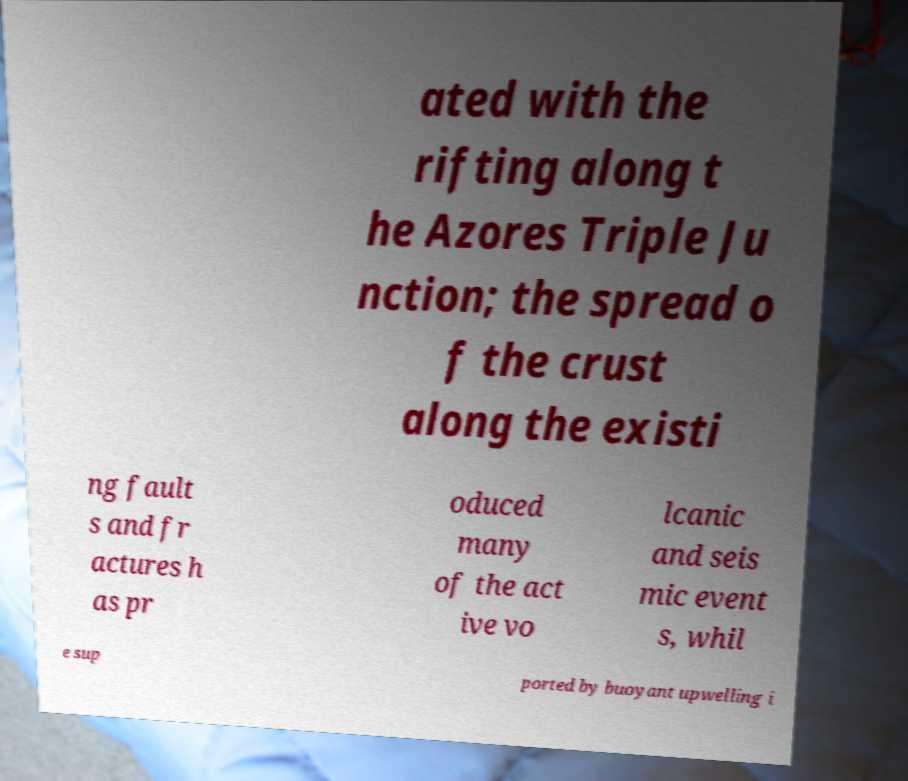Could you extract and type out the text from this image? ated with the rifting along t he Azores Triple Ju nction; the spread o f the crust along the existi ng fault s and fr actures h as pr oduced many of the act ive vo lcanic and seis mic event s, whil e sup ported by buoyant upwelling i 